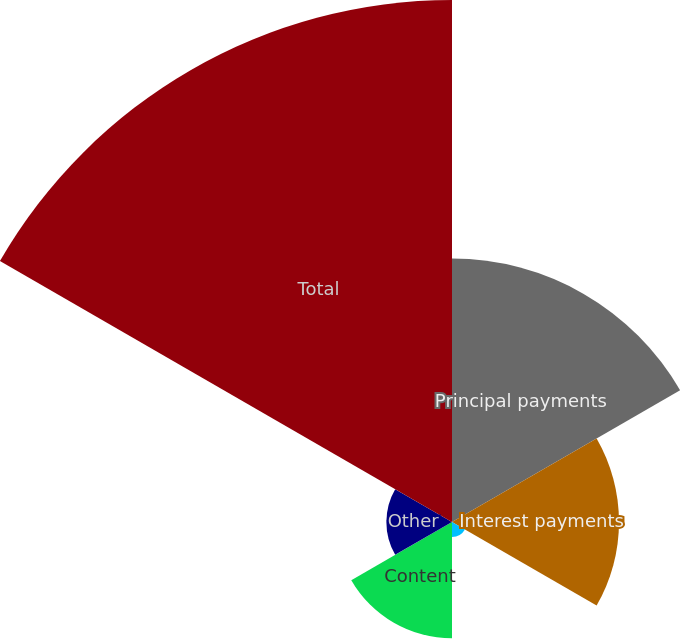Convert chart to OTSL. <chart><loc_0><loc_0><loc_500><loc_500><pie_chart><fcel>Principal payments<fcel>Interest payments<fcel>Operating lease obligations<fcel>Content<fcel>Other<fcel>Total<nl><fcel>22.92%<fcel>14.53%<fcel>1.3%<fcel>10.12%<fcel>5.71%<fcel>45.42%<nl></chart> 